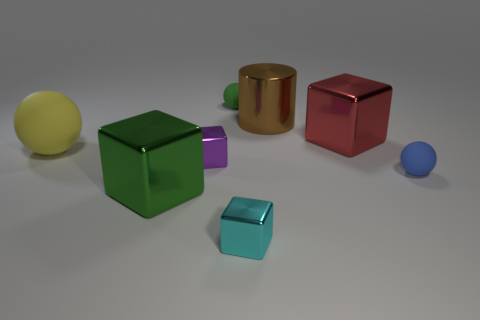What color is the big metallic object that is in front of the blue thing?
Ensure brevity in your answer.  Green. What number of other things are made of the same material as the small blue thing?
Your answer should be very brief. 2. Are there more large metal things that are in front of the big red object than things that are behind the yellow matte object?
Offer a very short reply. No. There is a big ball; what number of big objects are to the right of it?
Provide a short and direct response. 3. Is the large ball made of the same material as the large block that is to the left of the big red metallic object?
Provide a short and direct response. No. Are there any other things that have the same shape as the large yellow matte thing?
Offer a very short reply. Yes. Does the yellow sphere have the same material as the tiny blue ball?
Make the answer very short. Yes. There is a matte object left of the purple metallic thing; is there a big red thing that is in front of it?
Make the answer very short. No. How many small matte balls are in front of the purple shiny block and on the left side of the blue object?
Your answer should be compact. 0. There is a tiny object behind the large brown cylinder; what shape is it?
Provide a succinct answer. Sphere. 